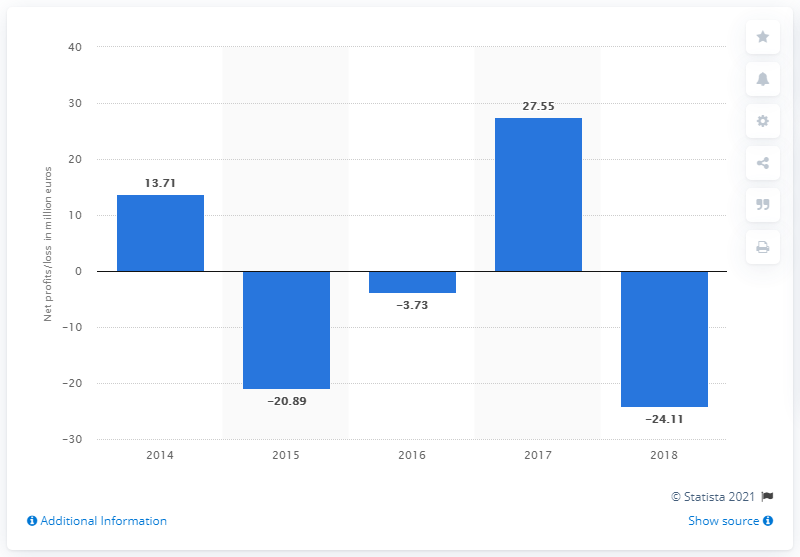Mention a couple of crucial points in this snapshot. Dolce & Gabbana's net profit in 2017 was 27.55 million. 